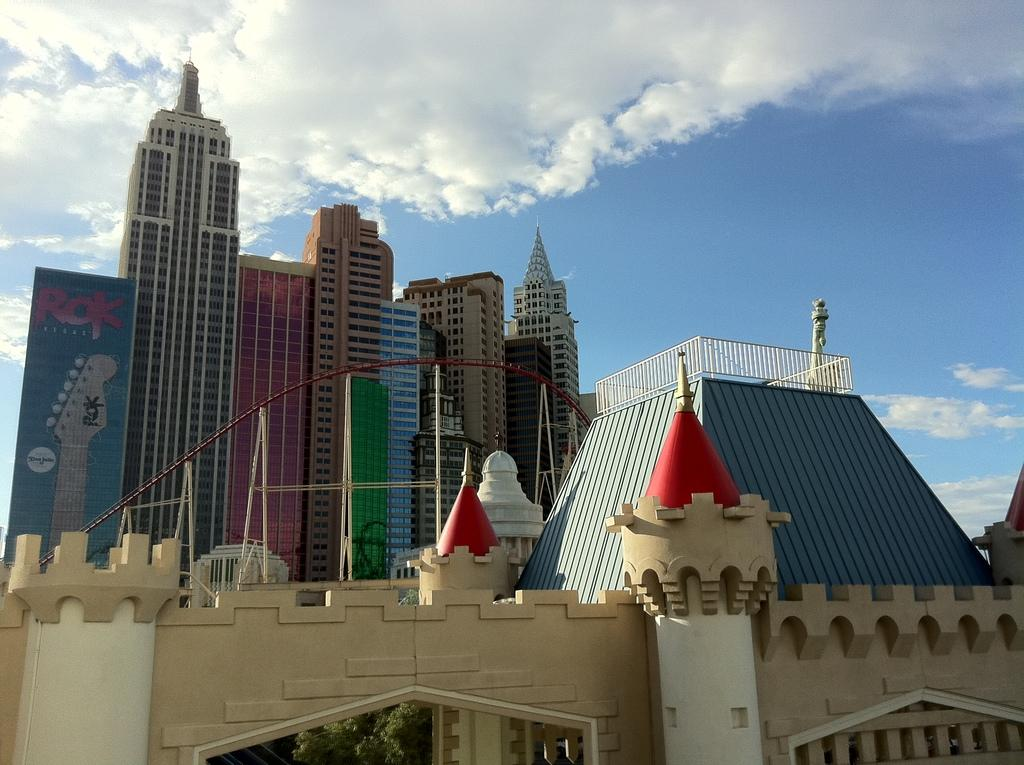What can be seen in the sky in the image? There are clouds in the sky in the image. What is the weather like in the image? It appears to be a sunny day in the image. What type of buildings are visible in the image? Skyscrapers are visible in the image. What is located at the bottom portion of the image? There is an arch and a tree at the bottom portion of the image. What hour is the horse depicted in the image? There is no horse present in the image. What type of knowledge is gained from the image? The image does not convey any specific knowledge; it is a visual representation of clouds, skyscrapers, an arch, and a tree. 